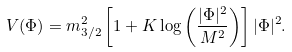Convert formula to latex. <formula><loc_0><loc_0><loc_500><loc_500>V ( \Phi ) = m _ { 3 / 2 } ^ { 2 } \left [ 1 + K \log \left ( \frac { | \Phi | ^ { 2 } } { M ^ { 2 } } \right ) \right ] | \Phi | ^ { 2 } .</formula> 